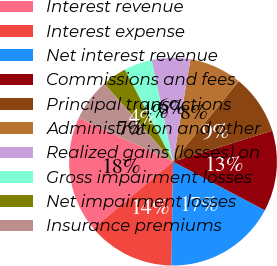Convert chart. <chart><loc_0><loc_0><loc_500><loc_500><pie_chart><fcel>Interest revenue<fcel>Interest expense<fcel>Net interest revenue<fcel>Commissions and fees<fcel>Principal transactions<fcel>Administration and other<fcel>Realized gains (losses) on<fcel>Gross impairment losses<fcel>Net impairment losses<fcel>Insurance premiums<nl><fcel>18.03%<fcel>13.66%<fcel>17.49%<fcel>12.57%<fcel>9.29%<fcel>8.2%<fcel>6.01%<fcel>4.37%<fcel>3.83%<fcel>6.56%<nl></chart> 